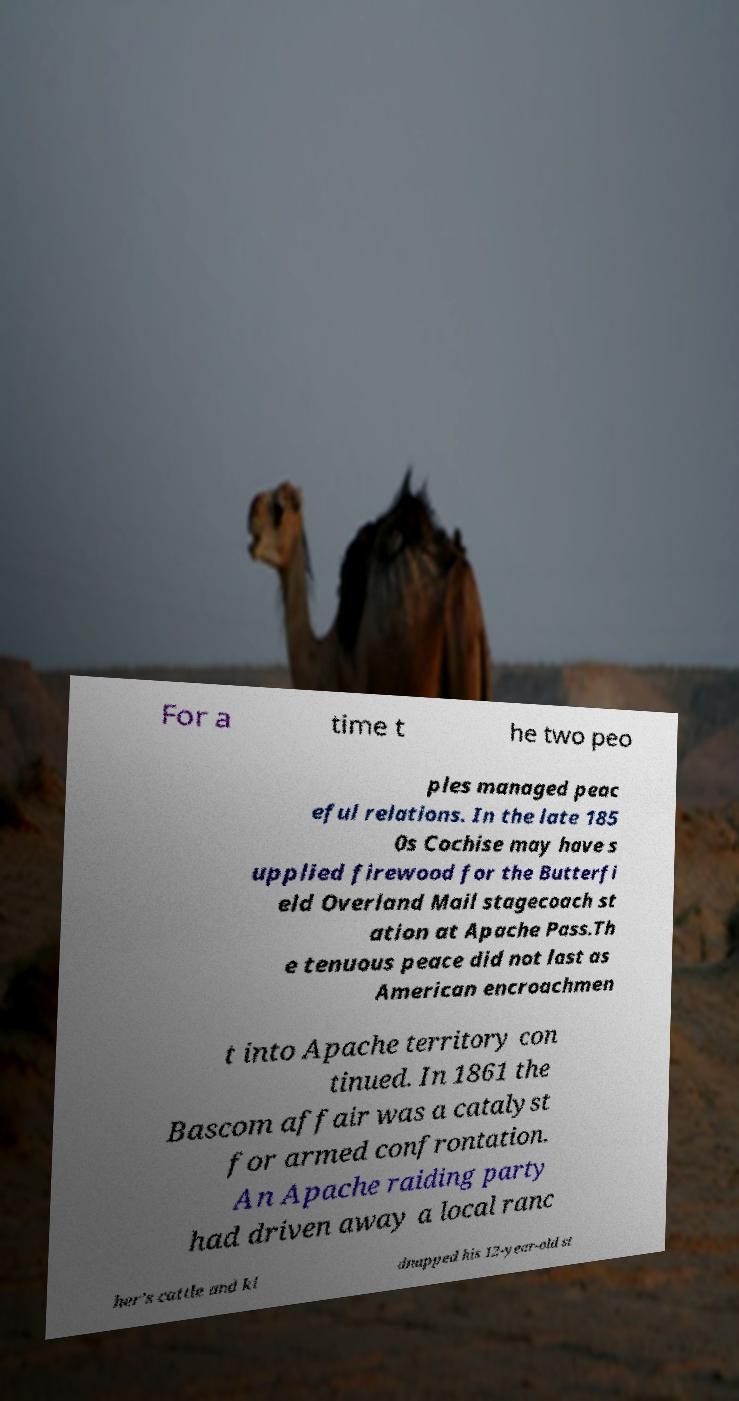Can you read and provide the text displayed in the image?This photo seems to have some interesting text. Can you extract and type it out for me? For a time t he two peo ples managed peac eful relations. In the late 185 0s Cochise may have s upplied firewood for the Butterfi eld Overland Mail stagecoach st ation at Apache Pass.Th e tenuous peace did not last as American encroachmen t into Apache territory con tinued. In 1861 the Bascom affair was a catalyst for armed confrontation. An Apache raiding party had driven away a local ranc her's cattle and ki dnapped his 12-year-old st 